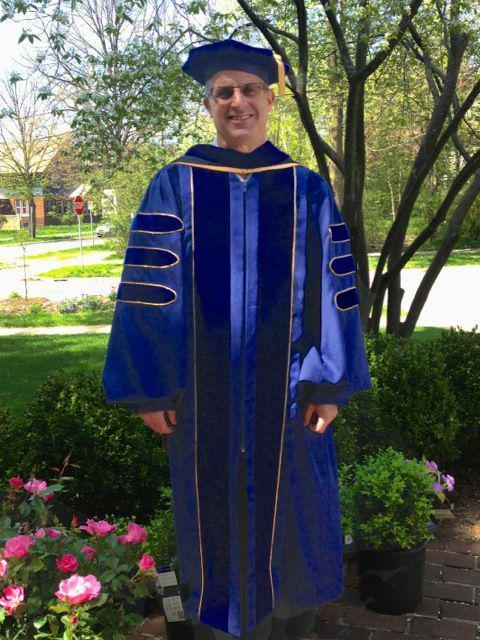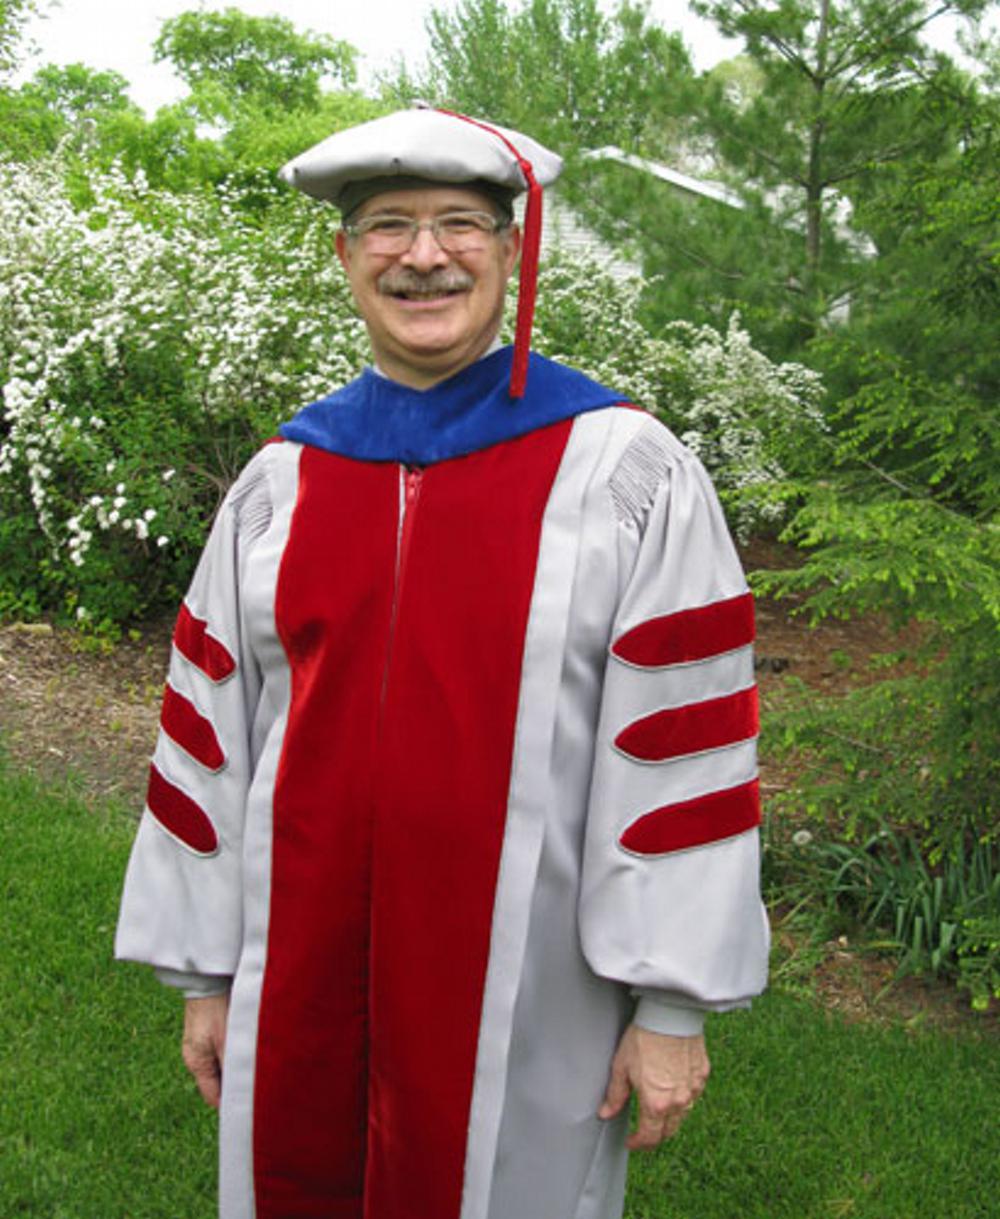The first image is the image on the left, the second image is the image on the right. Examine the images to the left and right. Is the description "Two people, one man and one woman, wearing graduation gowns and caps, each a different style, are seen facing front in full length photos." accurate? Answer yes or no. No. The first image is the image on the left, the second image is the image on the right. Examine the images to the left and right. Is the description "No graduate wears glasses, and the graduate in the right image is a male, while the graduate in the left image is female." accurate? Answer yes or no. No. 